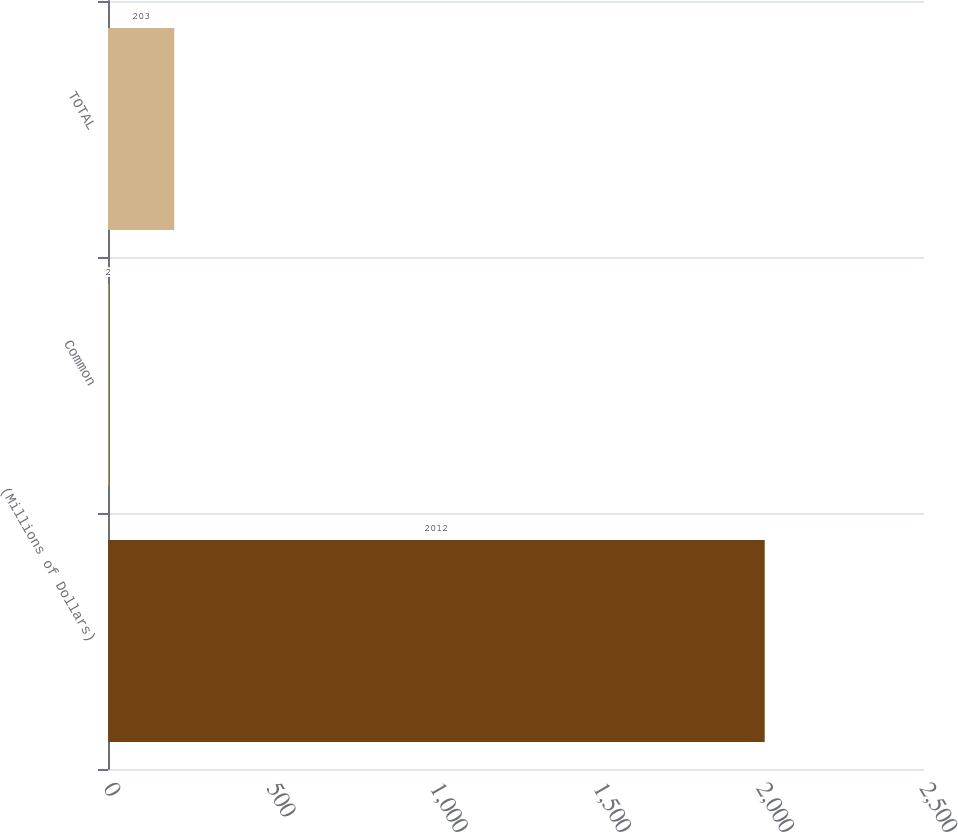<chart> <loc_0><loc_0><loc_500><loc_500><bar_chart><fcel>(Millions of Dollars)<fcel>Common<fcel>TOTAL<nl><fcel>2012<fcel>2<fcel>203<nl></chart> 